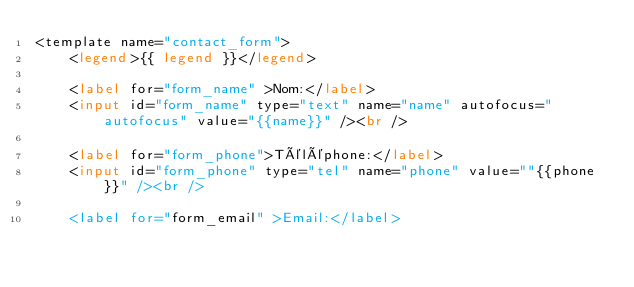<code> <loc_0><loc_0><loc_500><loc_500><_HTML_><template name="contact_form">
	<legend>{{ legend }}</legend>

	<label for="form_name" >Nom:</label>
	<input id="form_name" type="text" name="name" autofocus="autofocus" value="{{name}}" /><br />

	<label for="form_phone">Téléphone:</label>
	<input id="form_phone" type="tel" name="phone" value=""{{phone}}" /><br />

	<label for="form_email" >Email:</label></code> 